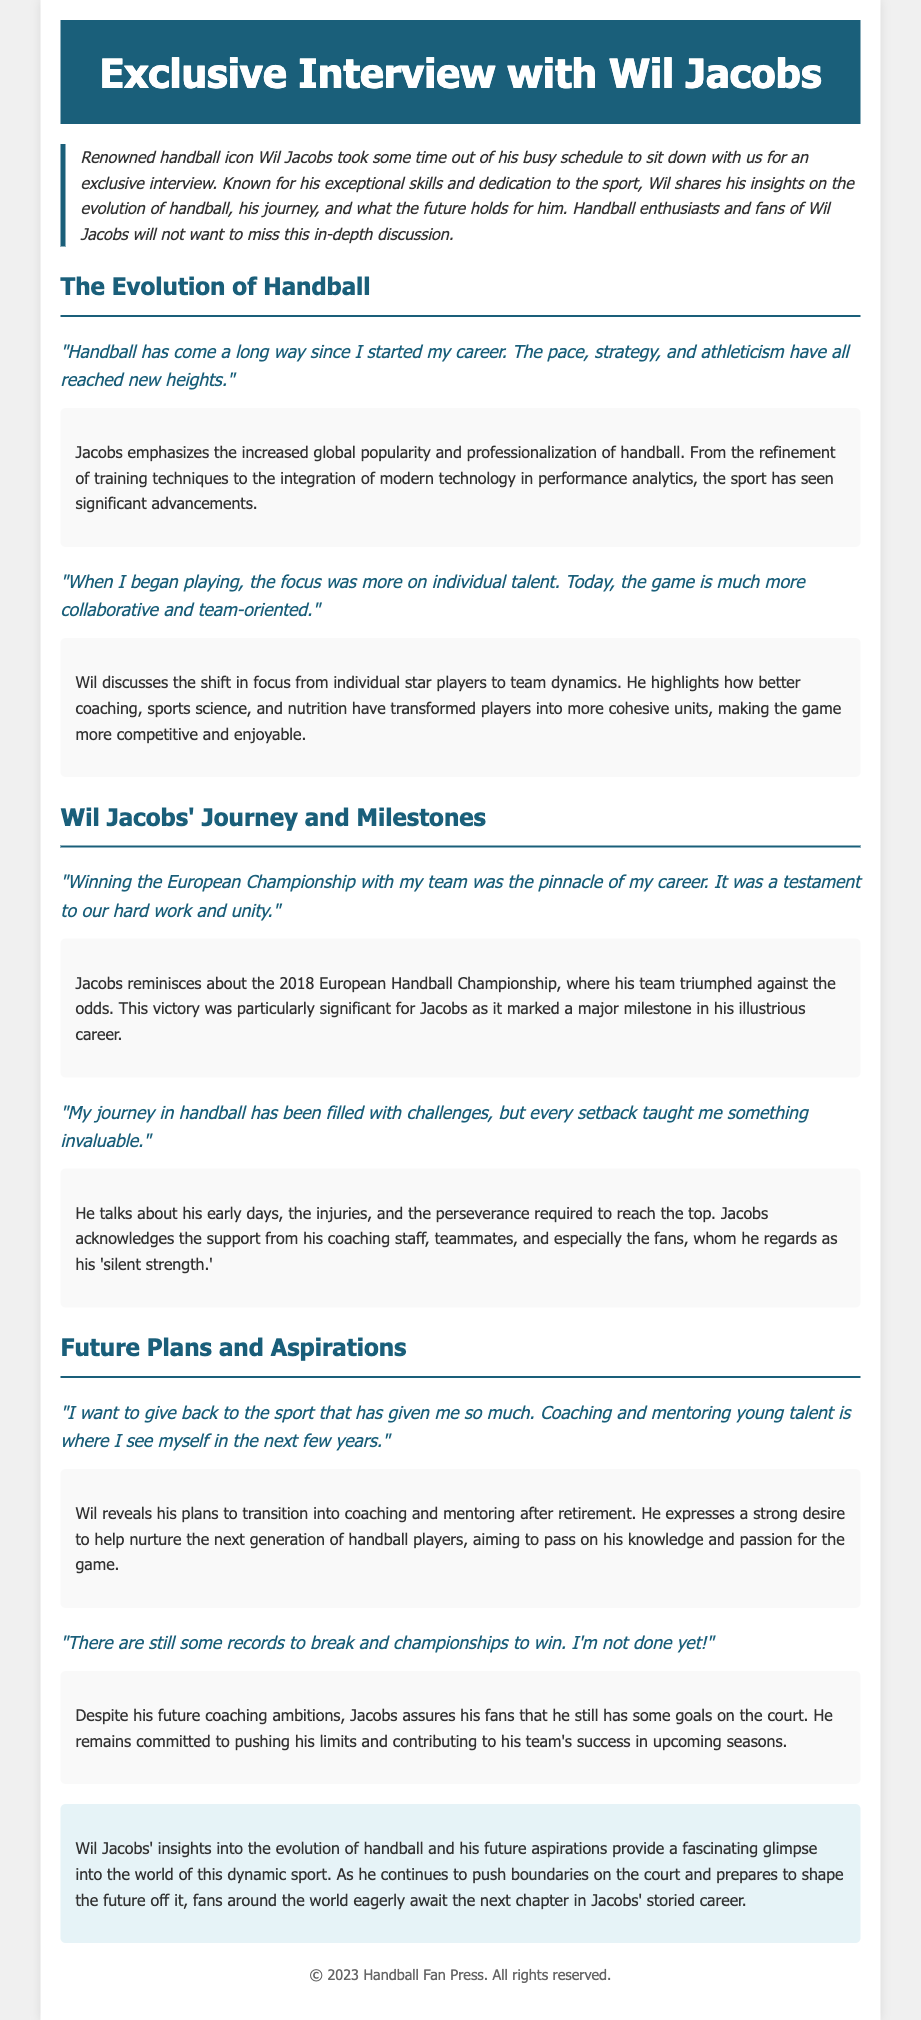What is the title of the press release? The title of the press release is clearly stated at the top of the document.
Answer: Exclusive Interview with Wil Jacobs Who is the handball icon discussed in the interview? The interview focuses on a specific individual known for his contribution to handball.
Answer: Wil Jacobs In what year did Wil Jacobs win the European Handball Championship? The document mentions this significant milestone during Jacobs' journey in handball.
Answer: 2018 What does Wil Jacobs want to pursue after retirement? Jacobs expresses his aspirations for his future career direction after retiring from play.
Answer: Coaching and mentoring What aspect of handball has changed according to Wil Jacobs? The quotes from Jacobs highlight a particular development in the sport over the years.
Answer: Team dynamics Which technology has influenced training techniques in handball? Jacobs mentions advancements in a specific area that have improved performance in the sport.
Answer: Modern technology What does Wil Jacobs call his fans? The document reveals how Jacobs refers to those who support him throughout his career.
Answer: Silent strength What is Wil Jacobs' attitude towards breaking records? The document indicates Jacobs' perspective on continuing to achieve success in handball.
Answer: Not done yet 